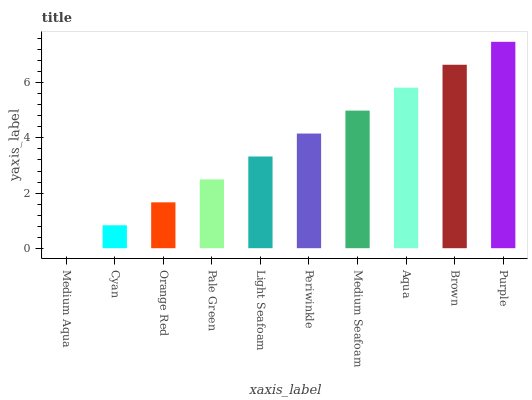Is Medium Aqua the minimum?
Answer yes or no. Yes. Is Purple the maximum?
Answer yes or no. Yes. Is Cyan the minimum?
Answer yes or no. No. Is Cyan the maximum?
Answer yes or no. No. Is Cyan greater than Medium Aqua?
Answer yes or no. Yes. Is Medium Aqua less than Cyan?
Answer yes or no. Yes. Is Medium Aqua greater than Cyan?
Answer yes or no. No. Is Cyan less than Medium Aqua?
Answer yes or no. No. Is Periwinkle the high median?
Answer yes or no. Yes. Is Light Seafoam the low median?
Answer yes or no. Yes. Is Orange Red the high median?
Answer yes or no. No. Is Purple the low median?
Answer yes or no. No. 